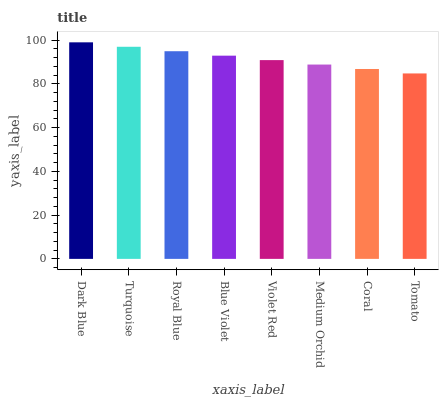Is Turquoise the minimum?
Answer yes or no. No. Is Turquoise the maximum?
Answer yes or no. No. Is Dark Blue greater than Turquoise?
Answer yes or no. Yes. Is Turquoise less than Dark Blue?
Answer yes or no. Yes. Is Turquoise greater than Dark Blue?
Answer yes or no. No. Is Dark Blue less than Turquoise?
Answer yes or no. No. Is Blue Violet the high median?
Answer yes or no. Yes. Is Violet Red the low median?
Answer yes or no. Yes. Is Turquoise the high median?
Answer yes or no. No. Is Blue Violet the low median?
Answer yes or no. No. 